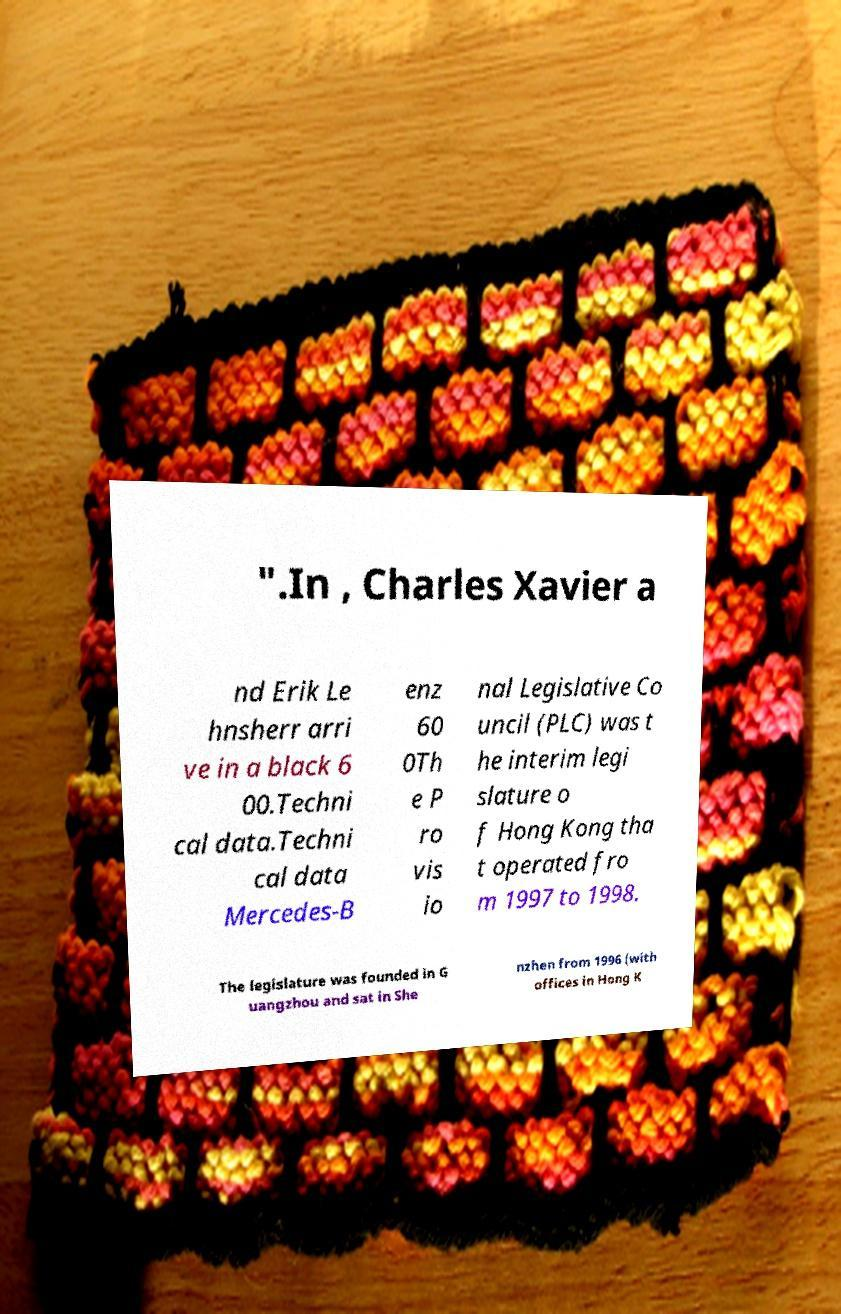I need the written content from this picture converted into text. Can you do that? ".In , Charles Xavier a nd Erik Le hnsherr arri ve in a black 6 00.Techni cal data.Techni cal data Mercedes-B enz 60 0Th e P ro vis io nal Legislative Co uncil (PLC) was t he interim legi slature o f Hong Kong tha t operated fro m 1997 to 1998. The legislature was founded in G uangzhou and sat in She nzhen from 1996 (with offices in Hong K 